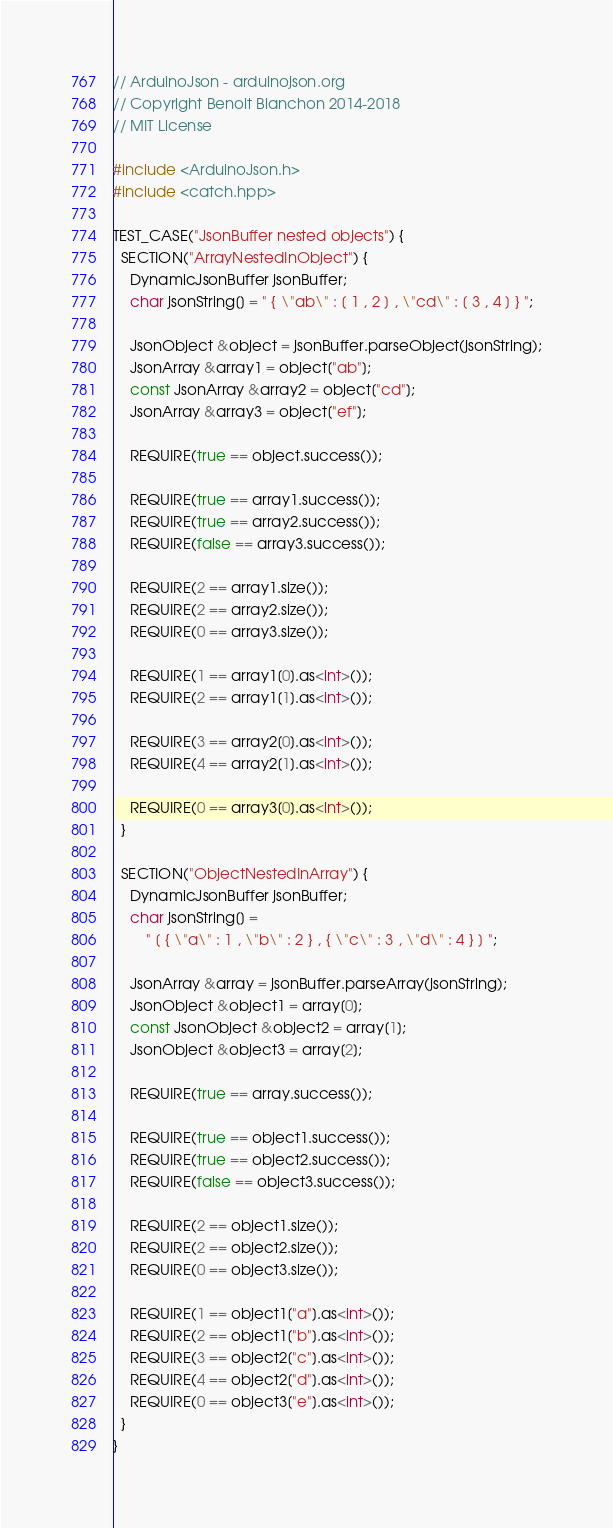<code> <loc_0><loc_0><loc_500><loc_500><_C++_>// ArduinoJson - arduinojson.org
// Copyright Benoit Blanchon 2014-2018
// MIT License

#include <ArduinoJson.h>
#include <catch.hpp>

TEST_CASE("JsonBuffer nested objects") {
  SECTION("ArrayNestedInObject") {
    DynamicJsonBuffer jsonBuffer;
    char jsonString[] = " { \"ab\" : [ 1 , 2 ] , \"cd\" : [ 3 , 4 ] } ";

    JsonObject &object = jsonBuffer.parseObject(jsonString);
    JsonArray &array1 = object["ab"];
    const JsonArray &array2 = object["cd"];
    JsonArray &array3 = object["ef"];

    REQUIRE(true == object.success());

    REQUIRE(true == array1.success());
    REQUIRE(true == array2.success());
    REQUIRE(false == array3.success());

    REQUIRE(2 == array1.size());
    REQUIRE(2 == array2.size());
    REQUIRE(0 == array3.size());

    REQUIRE(1 == array1[0].as<int>());
    REQUIRE(2 == array1[1].as<int>());

    REQUIRE(3 == array2[0].as<int>());
    REQUIRE(4 == array2[1].as<int>());

    REQUIRE(0 == array3[0].as<int>());
  }

  SECTION("ObjectNestedInArray") {
    DynamicJsonBuffer jsonBuffer;
    char jsonString[] =
        " [ { \"a\" : 1 , \"b\" : 2 } , { \"c\" : 3 , \"d\" : 4 } ] ";

    JsonArray &array = jsonBuffer.parseArray(jsonString);
    JsonObject &object1 = array[0];
    const JsonObject &object2 = array[1];
    JsonObject &object3 = array[2];

    REQUIRE(true == array.success());

    REQUIRE(true == object1.success());
    REQUIRE(true == object2.success());
    REQUIRE(false == object3.success());

    REQUIRE(2 == object1.size());
    REQUIRE(2 == object2.size());
    REQUIRE(0 == object3.size());

    REQUIRE(1 == object1["a"].as<int>());
    REQUIRE(2 == object1["b"].as<int>());
    REQUIRE(3 == object2["c"].as<int>());
    REQUIRE(4 == object2["d"].as<int>());
    REQUIRE(0 == object3["e"].as<int>());
  }
}
</code> 